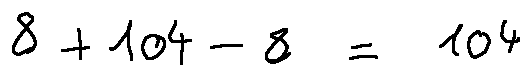Convert formula to latex. <formula><loc_0><loc_0><loc_500><loc_500>8 + 1 0 4 - 8 = 1 0 4</formula> 